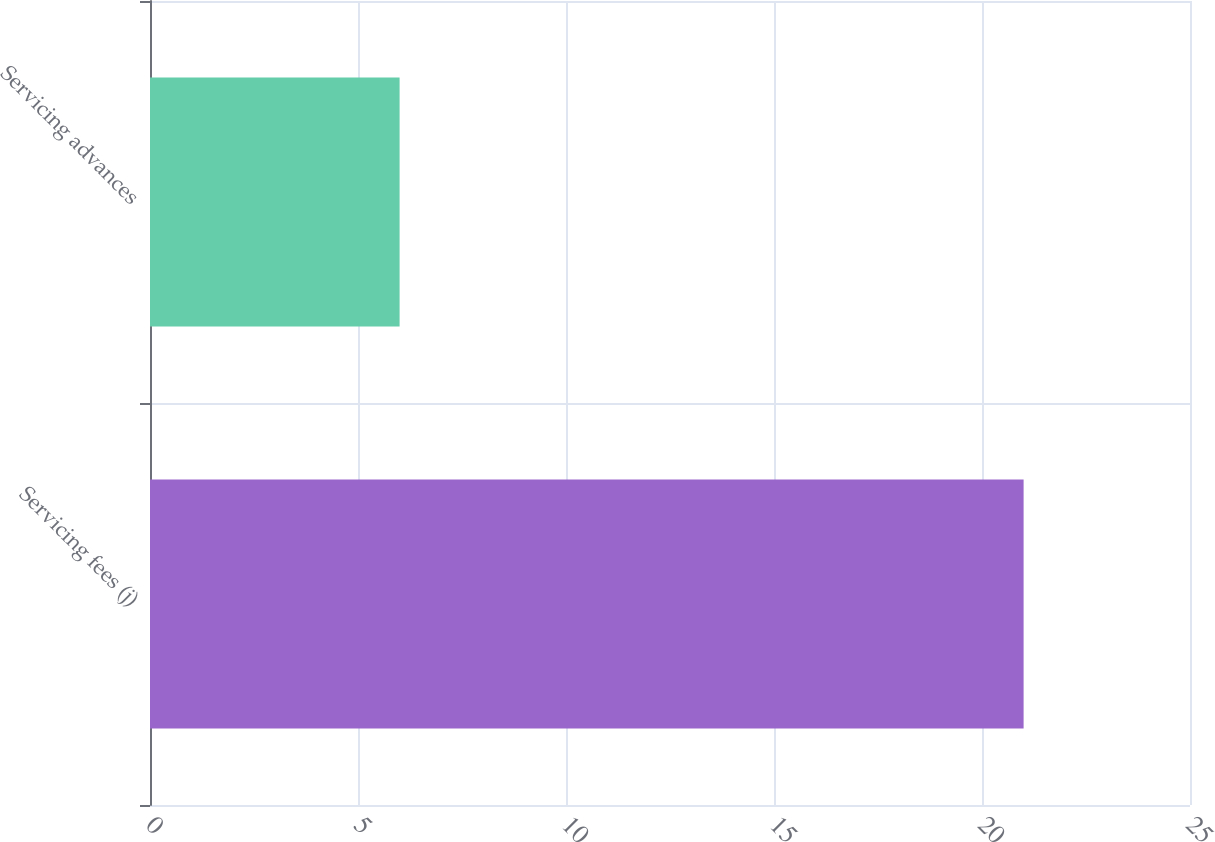Convert chart to OTSL. <chart><loc_0><loc_0><loc_500><loc_500><bar_chart><fcel>Servicing fees (j)<fcel>Servicing advances<nl><fcel>21<fcel>6<nl></chart> 